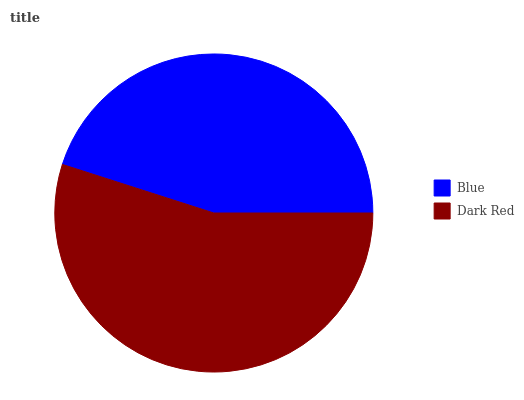Is Blue the minimum?
Answer yes or no. Yes. Is Dark Red the maximum?
Answer yes or no. Yes. Is Dark Red the minimum?
Answer yes or no. No. Is Dark Red greater than Blue?
Answer yes or no. Yes. Is Blue less than Dark Red?
Answer yes or no. Yes. Is Blue greater than Dark Red?
Answer yes or no. No. Is Dark Red less than Blue?
Answer yes or no. No. Is Dark Red the high median?
Answer yes or no. Yes. Is Blue the low median?
Answer yes or no. Yes. Is Blue the high median?
Answer yes or no. No. Is Dark Red the low median?
Answer yes or no. No. 